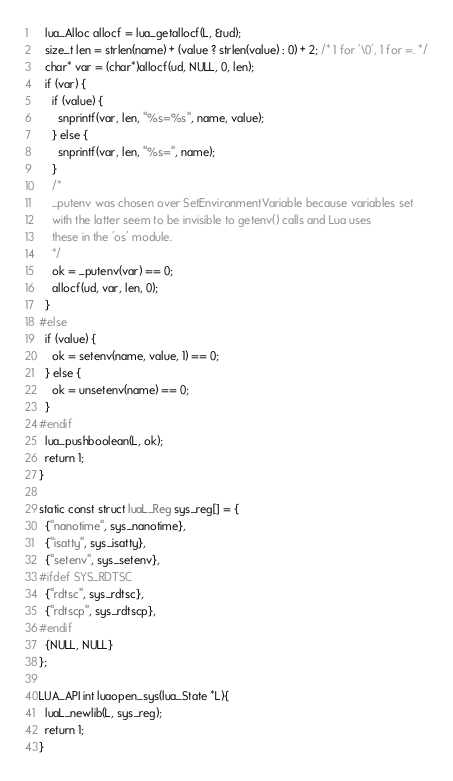Convert code to text. <code><loc_0><loc_0><loc_500><loc_500><_C_>  lua_Alloc allocf = lua_getallocf(L, &ud);
  size_t len = strlen(name) + (value ? strlen(value) : 0) + 2; /* 1 for '\0', 1 for =. */
  char* var = (char*)allocf(ud, NULL, 0, len);
  if (var) {
    if (value) {
      snprintf(var, len, "%s=%s", name, value);
    } else {
      snprintf(var, len, "%s=", name);
    }
    /*
    _putenv was chosen over SetEnvironmentVariable because variables set
    with the latter seem to be invisible to getenv() calls and Lua uses
    these in the 'os' module.
    */
    ok = _putenv(var) == 0;
    allocf(ud, var, len, 0);
  }
#else
  if (value) {
    ok = setenv(name, value, 1) == 0;
  } else {
    ok = unsetenv(name) == 0;
  }
#endif
  lua_pushboolean(L, ok);
  return 1;
}

static const struct luaL_Reg sys_reg[] = {
  {"nanotime", sys_nanotime},
  {"isatty", sys_isatty},
  {"setenv", sys_setenv},
#ifdef SYS_RDTSC
  {"rdtsc", sys_rdtsc},
  {"rdtscp", sys_rdtscp},
#endif
  {NULL, NULL}
};

LUA_API int luaopen_sys(lua_State *L){
  luaL_newlib(L, sys_reg);
  return 1;
}
</code> 